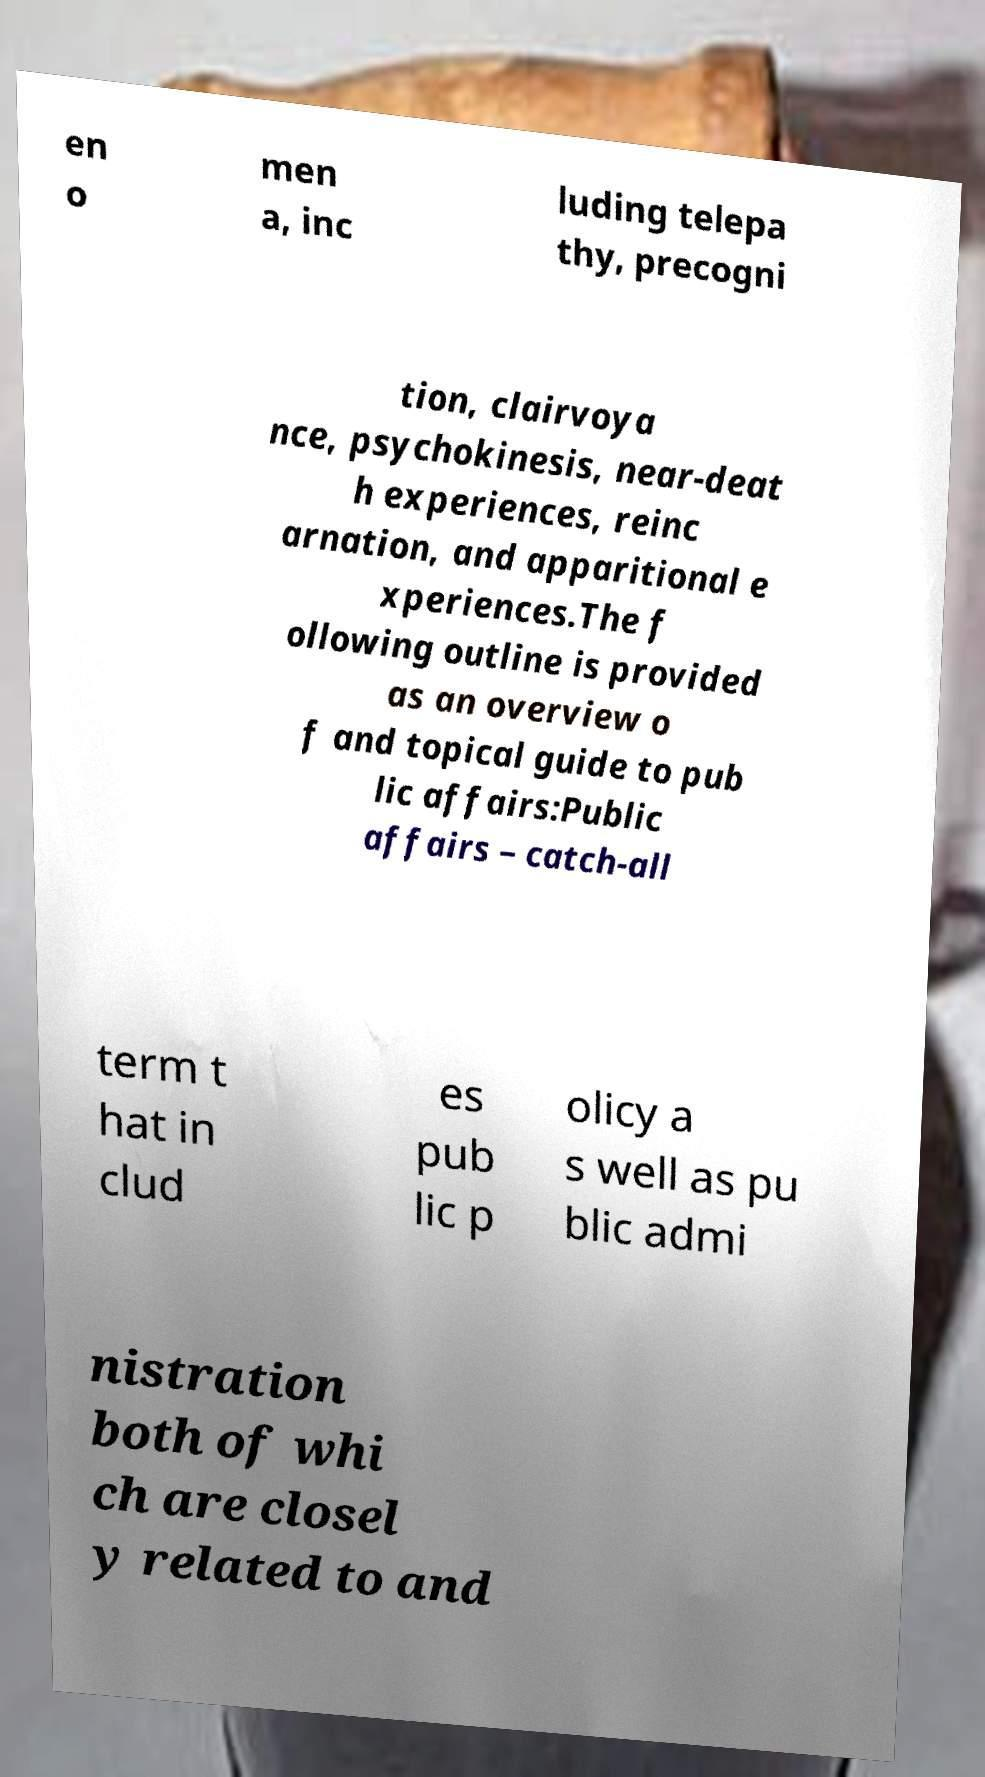Can you read and provide the text displayed in the image?This photo seems to have some interesting text. Can you extract and type it out for me? en o men a, inc luding telepa thy, precogni tion, clairvoya nce, psychokinesis, near-deat h experiences, reinc arnation, and apparitional e xperiences.The f ollowing outline is provided as an overview o f and topical guide to pub lic affairs:Public affairs – catch-all term t hat in clud es pub lic p olicy a s well as pu blic admi nistration both of whi ch are closel y related to and 